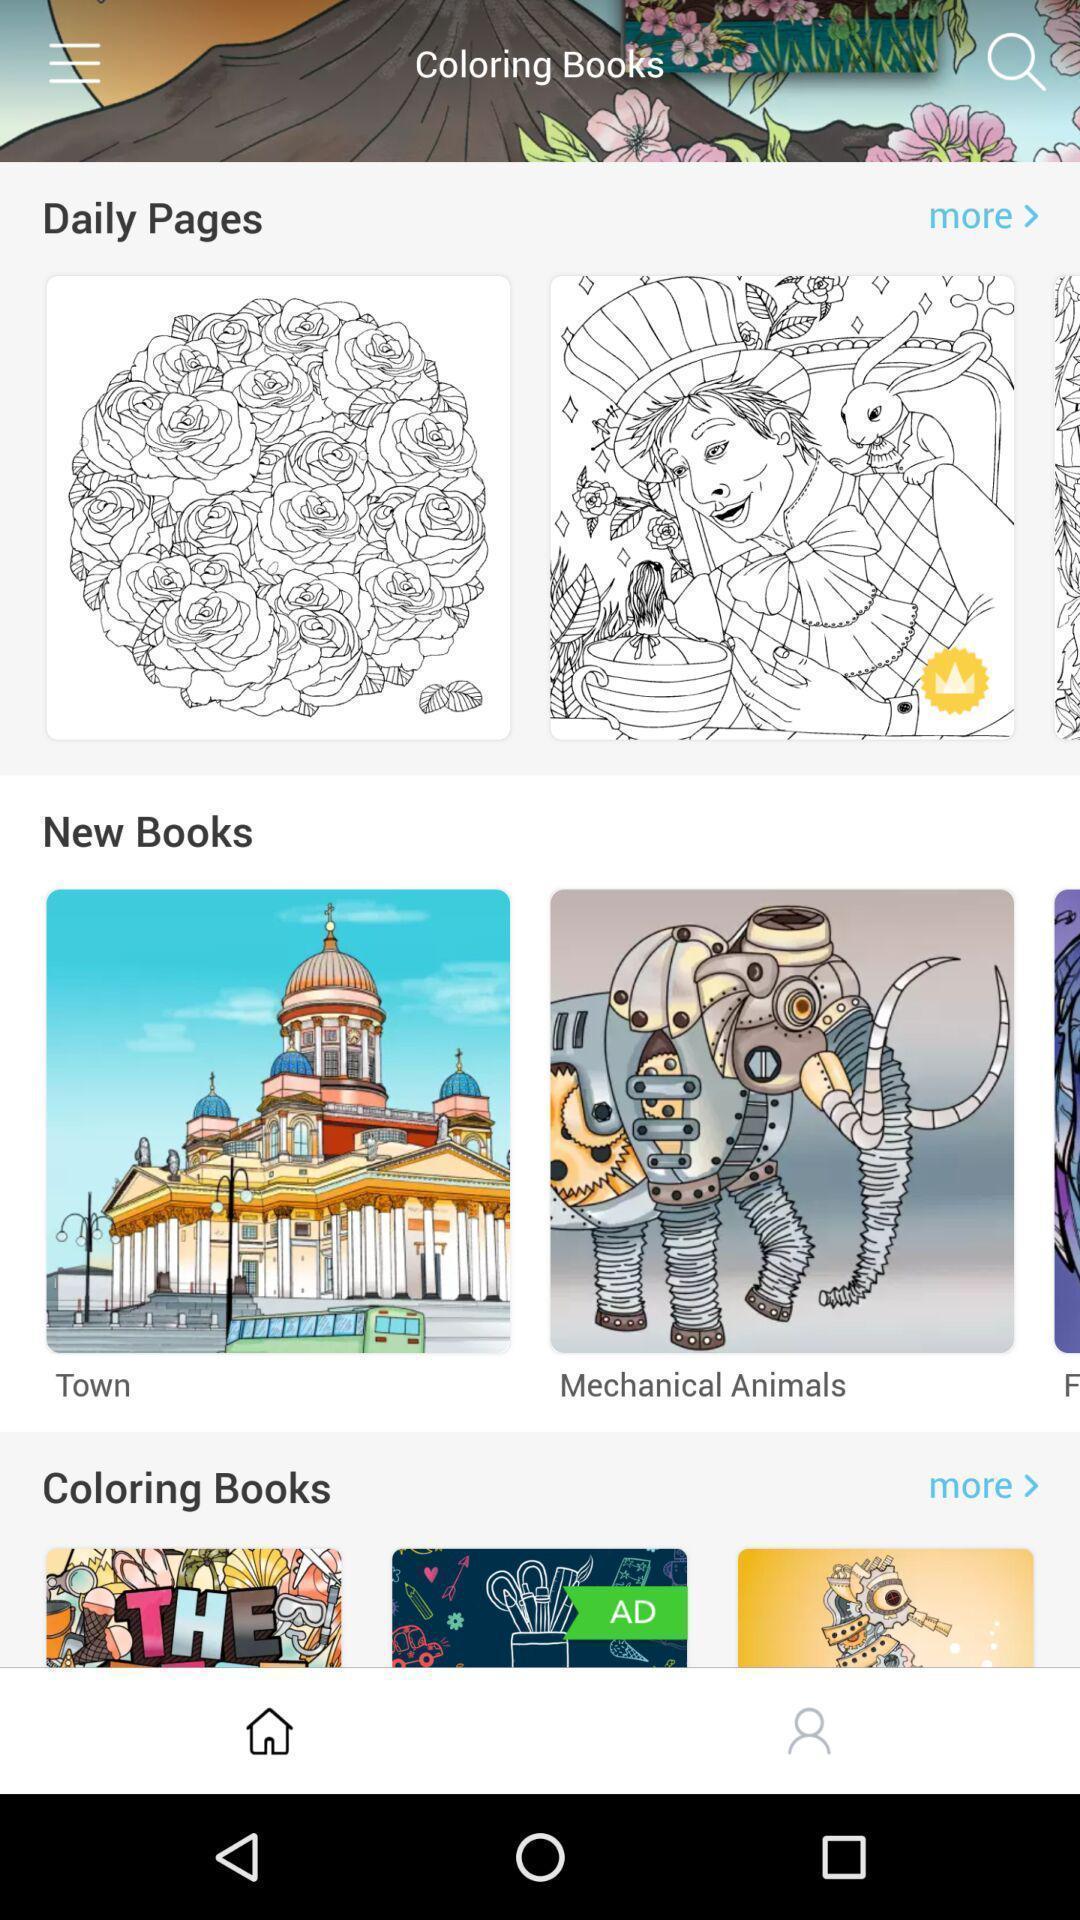Provide a description of this screenshot. Screen displaying images in various categories. 